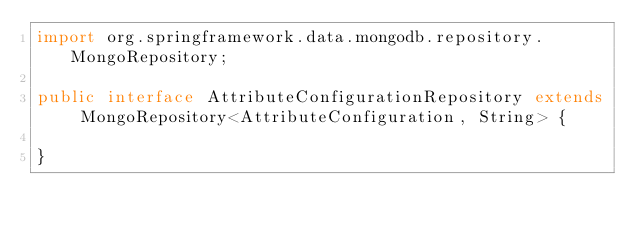<code> <loc_0><loc_0><loc_500><loc_500><_Java_>import org.springframework.data.mongodb.repository.MongoRepository;

public interface AttributeConfigurationRepository extends MongoRepository<AttributeConfiguration, String> {

}
</code> 